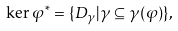<formula> <loc_0><loc_0><loc_500><loc_500>\ker \varphi ^ { * } = \{ D _ { \gamma } | \gamma \subseteq \gamma ( \varphi ) \} ,</formula> 